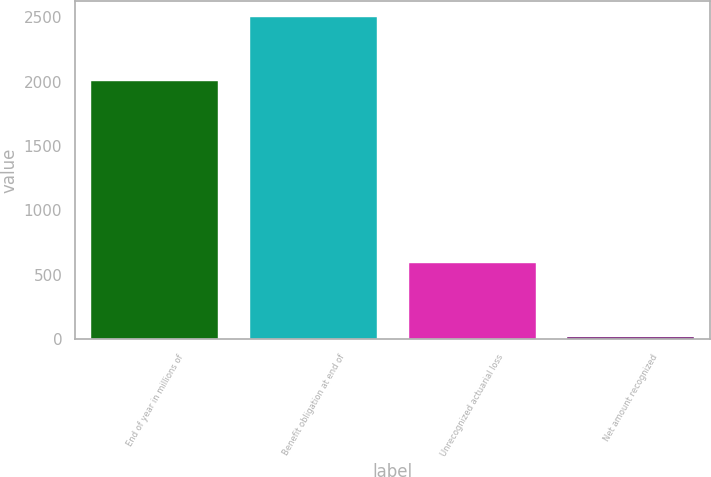Convert chart to OTSL. <chart><loc_0><loc_0><loc_500><loc_500><bar_chart><fcel>End of year in millions of<fcel>Benefit obligation at end of<fcel>Unrecognized actuarial loss<fcel>Net amount recognized<nl><fcel>2003<fcel>2501<fcel>594<fcel>22<nl></chart> 